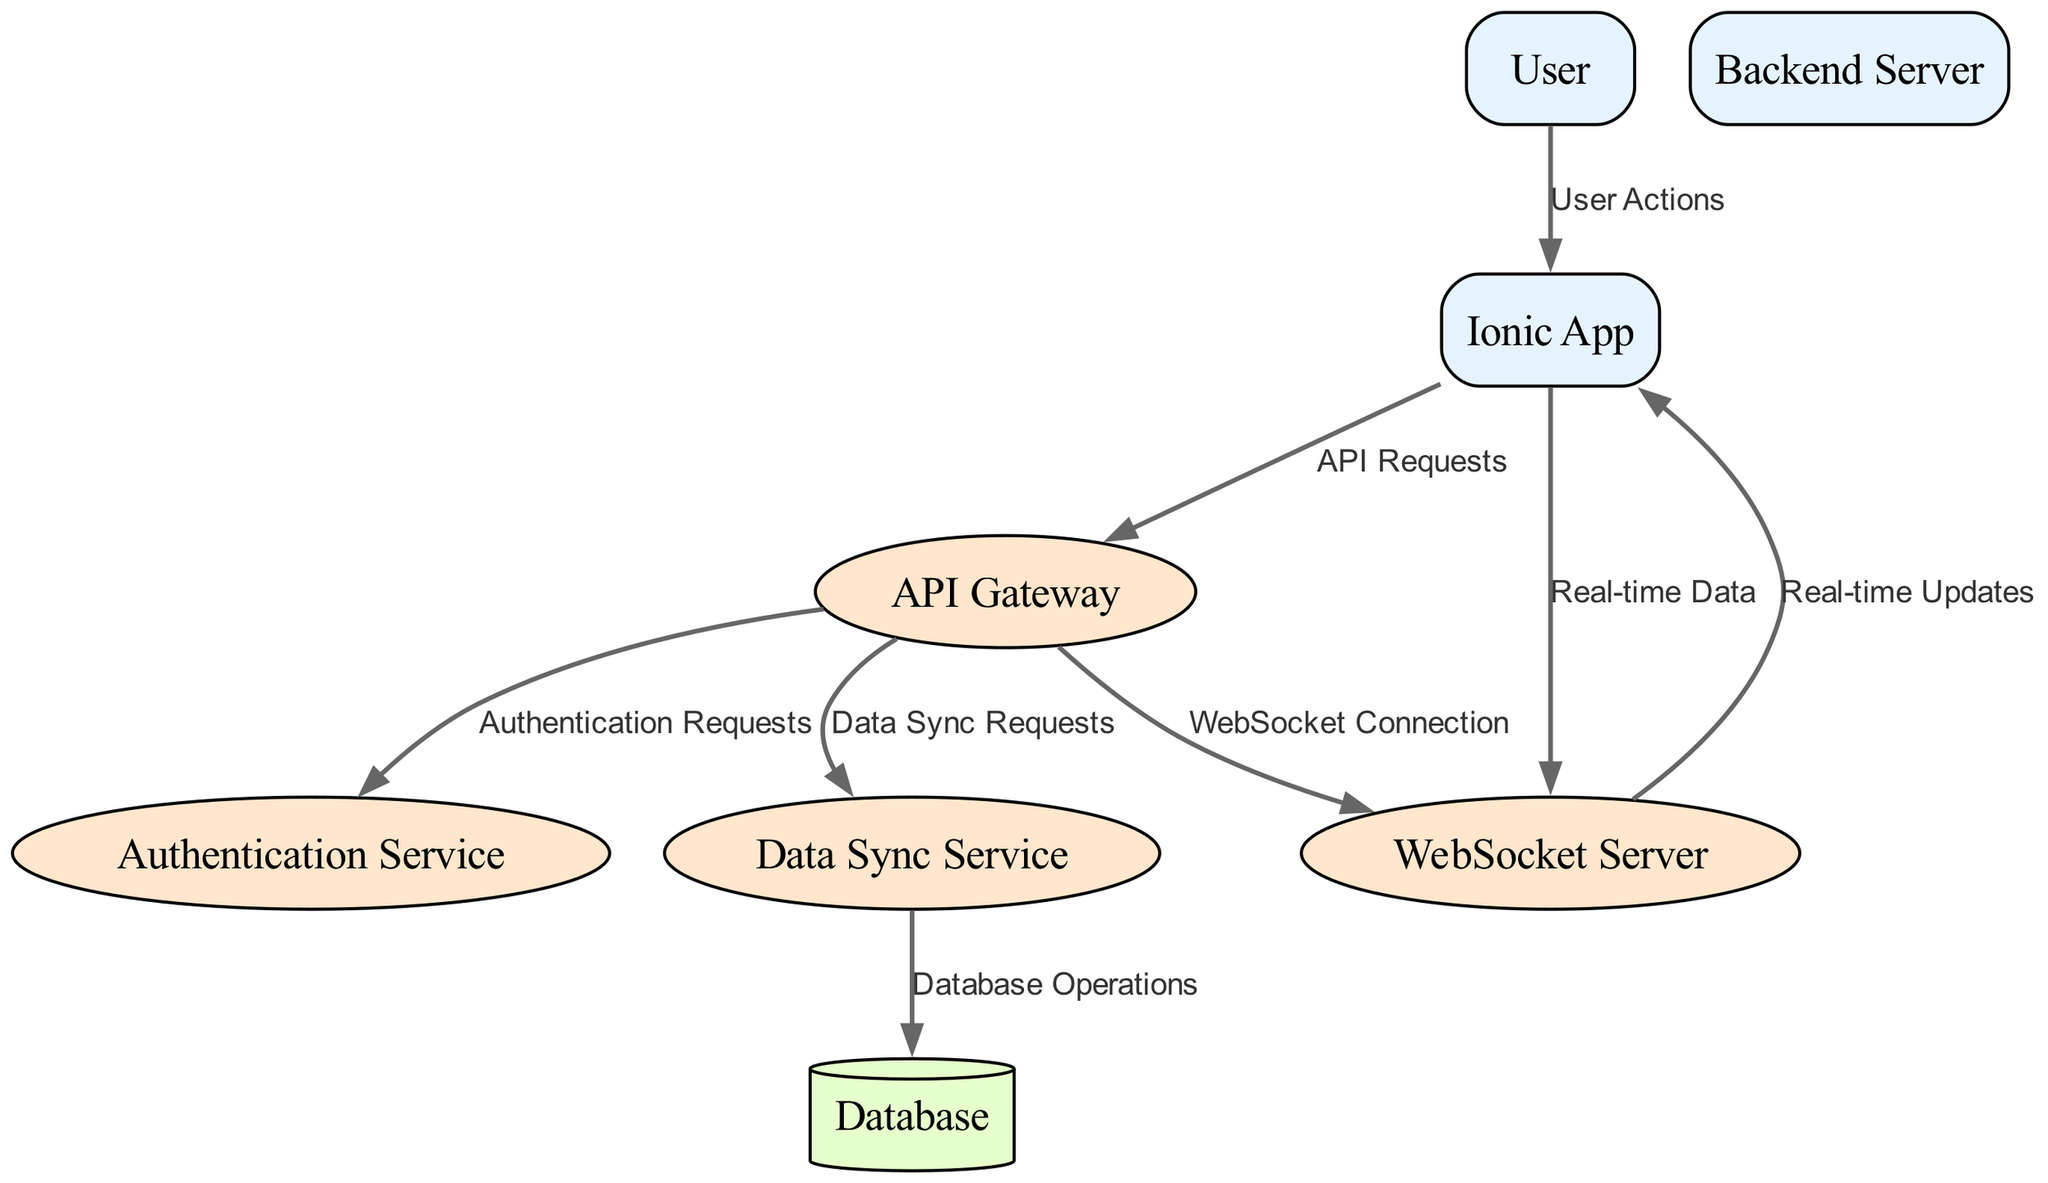What is the number of external entities in the diagram? The diagram features three external entities: Ionic App, User, and Backend Server. By counting the entities listed, we arrive at the total.
Answer: 3 Which component handles user authentication? The Authentication Service specifically manages user authentication and authorization, as described in the diagram. It is directly connected from the API Gateway for related requests.
Answer: Authentication Service What type of connection does the WebSocket Server establish with the Ionic App? The WebSocket Server facilitates a real-time connection with the Ionic App, as illustrated in the data flow labeled 'Real-time Updates.'
Answer: Real-time connection From where does the Data Sync Service receive requests? The Data Sync Service receives requests from the API Gateway, which directs all relevant data sync operations to manage real-time synchronization of data.
Answer: API Gateway How many processes are involved in the communication flow? There are four processes in the diagram: API Gateway, Authentication Service, Data Sync Service, and WebSocket Server. These processes manage data flow between the external entities and the database.
Answer: 4 What data is sent from the Ionic App to the WebSocket Server? The Ionic App sends Real-time Data to the WebSocket Server, allowing for immediate updates and communication. This is explicitly represented in the flow labeled 'Real-time Data.'
Answer: Real-time Data Which data store is used for persistent data in the architecture? The Database is the designated Data Store in this architecture that retains all persistent data required by the Ionic App and backend services, as mentioned in the diagram.
Answer: Database What is the purpose of the API Gateway in this system? The API Gateway acts as the entry point for all API requests, channeling them to appropriate backend services, including the Data Sync Service and Authentication Service.
Answer: Entry point for API requests Which service is responsible for real-time updates to the Ionic App? The WebSocket Server is responsible for pushing real-time updates from the server to the Ionic App, facilitating an interactive experience for users.
Answer: WebSocket Server 